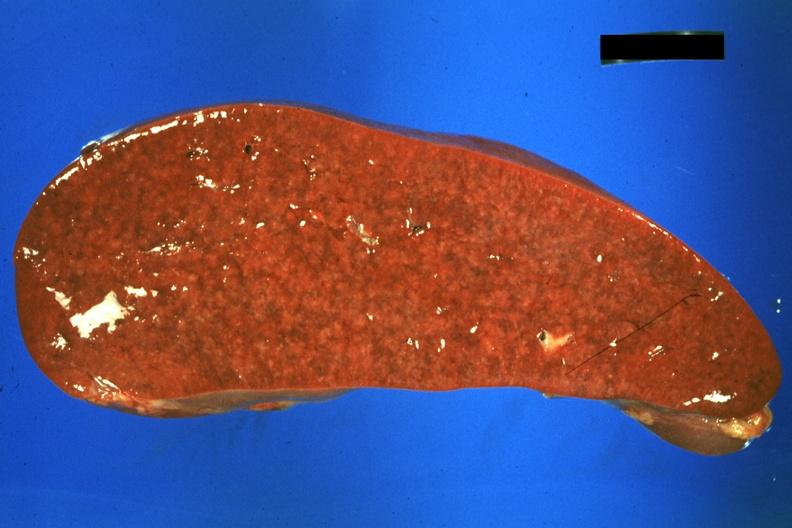where is this part in?
Answer the question using a single word or phrase. Spleen 